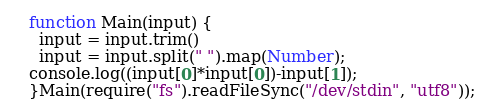Convert code to text. <code><loc_0><loc_0><loc_500><loc_500><_JavaScript_>function Main(input) {
  input = input.trim()
  input = input.split(" ").map(Number);
console.log((input[0]*input[0])-input[1]);
}Main(require("fs").readFileSync("/dev/stdin", "utf8"));</code> 